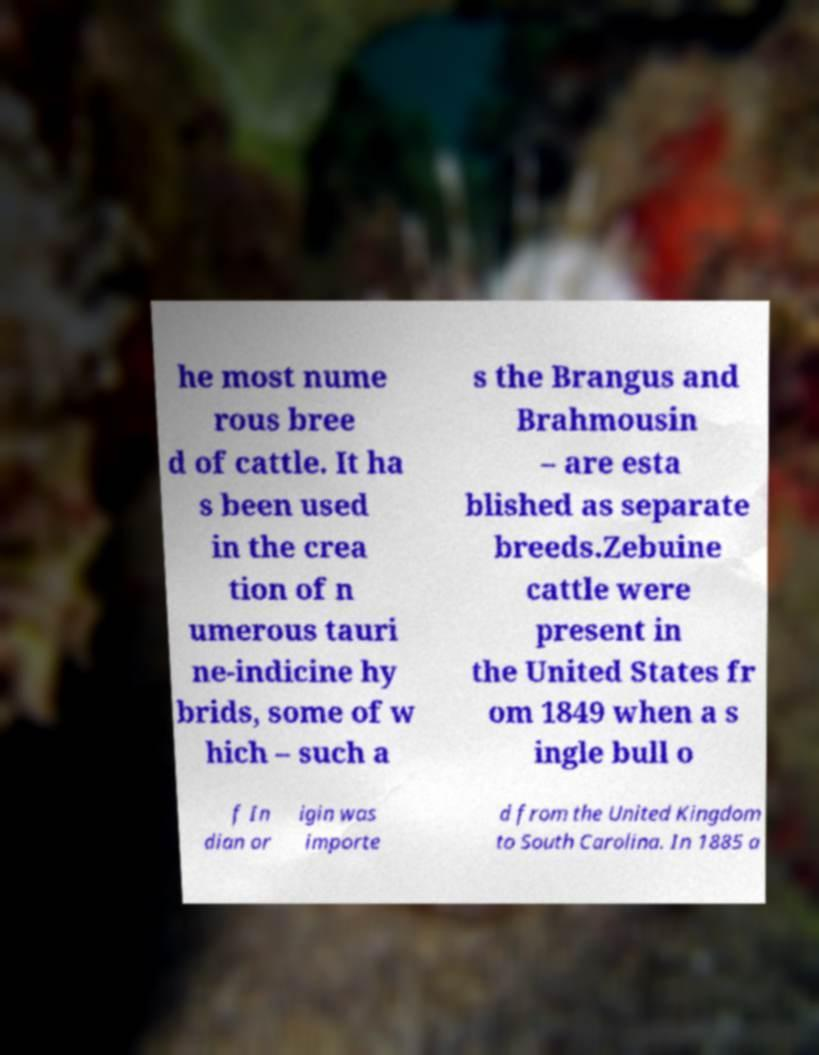Can you read and provide the text displayed in the image?This photo seems to have some interesting text. Can you extract and type it out for me? he most nume rous bree d of cattle. It ha s been used in the crea tion of n umerous tauri ne-indicine hy brids, some of w hich – such a s the Brangus and Brahmousin – are esta blished as separate breeds.Zebuine cattle were present in the United States fr om 1849 when a s ingle bull o f In dian or igin was importe d from the United Kingdom to South Carolina. In 1885 a 